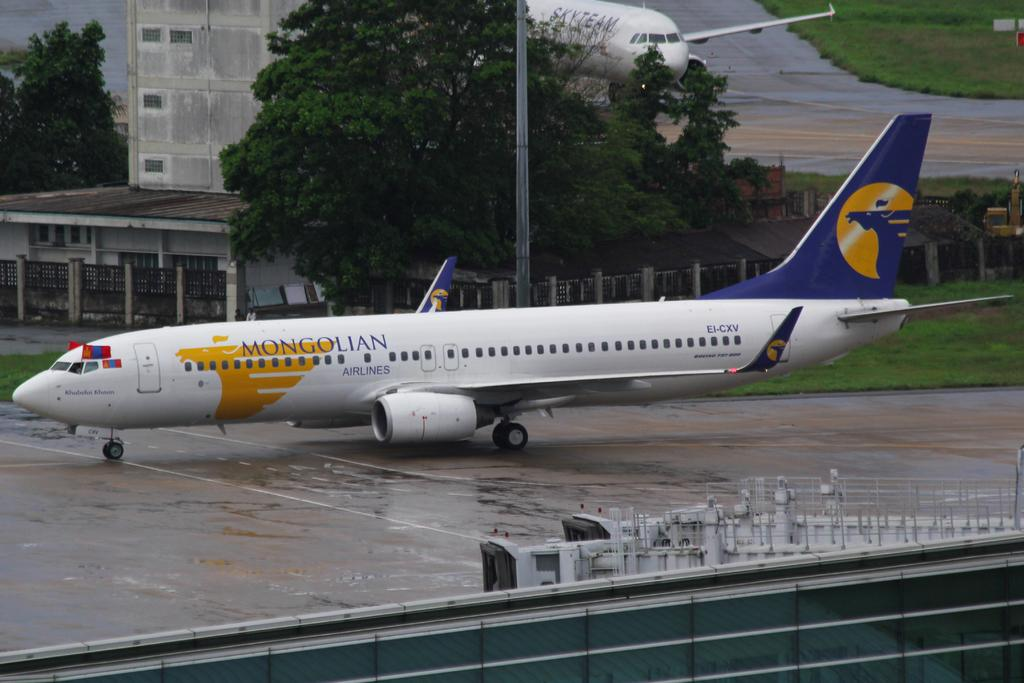<image>
Present a compact description of the photo's key features. A plane has Mongolian Airlines painted on its side. 